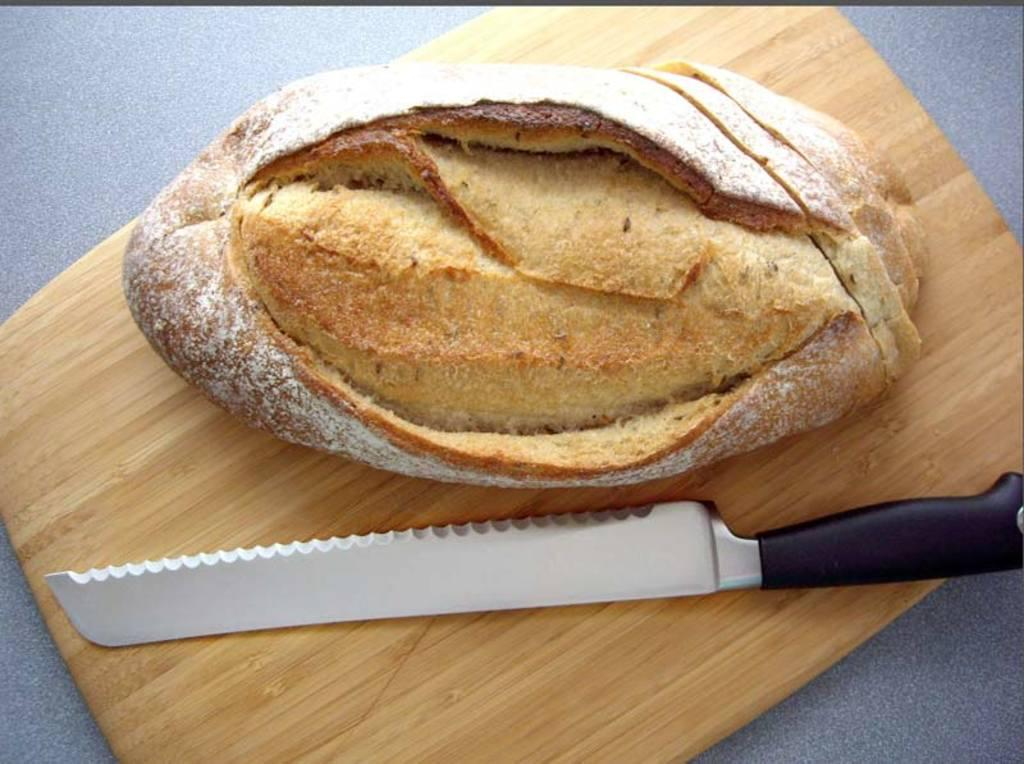What is the surface on which the objects are placed in the image? All of these objects are on a table in the image. What is the main object used for cutting in the image? There is a knife in the image. What type of food item can be seen in the image? There is a bun in the image. What is the object used for cutting on that is also present in the image? There is a chopping pad in the image. How many legs can be seen on the pie in the image? There is no pie present in the image, and therefore no legs can be observed. What type of creature is shown interacting with the bun on the table in the image? There is no creature shown interacting with the bun on the table in the image; only the chopping pad, knife, and bun are present. 